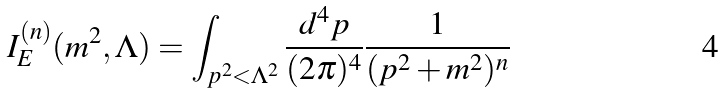Convert formula to latex. <formula><loc_0><loc_0><loc_500><loc_500>I ^ { ( n ) } _ { E } ( m ^ { 2 } , \Lambda ) = \int _ { p ^ { 2 } < \Lambda ^ { 2 } } \frac { d ^ { 4 } p } { ( 2 \pi ) ^ { 4 } } \frac { 1 } { ( p ^ { 2 } + m ^ { 2 } ) ^ { n } }</formula> 